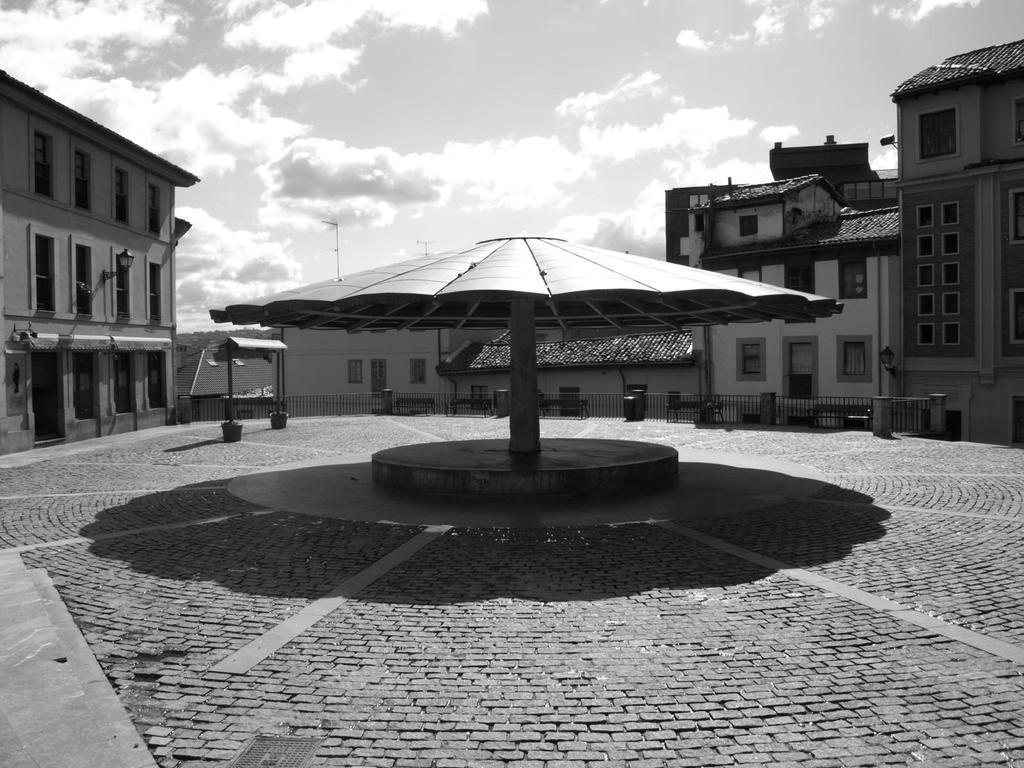What can be seen at the bottom of the image? The ground is visible in the image. What structure is present in the image? There is a shelter in the image. What type of barrier is in the image? There is a fence in the image. What type of seating is available in the image? There are benches in the image. What type of buildings can be seen in the image? There are buildings with windows in the image. What else is present in the image? There are some objects in the image. What can be seen in the background of the image? The sky is visible in the background of the image. What is present in the sky? Clouds are present in the sky. Can you see a river flowing through the image? No, there is no river present in the image. What type of mint is growing near the benches in the image? There is no mint present in the image. 